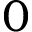<formula> <loc_0><loc_0><loc_500><loc_500>0</formula> 